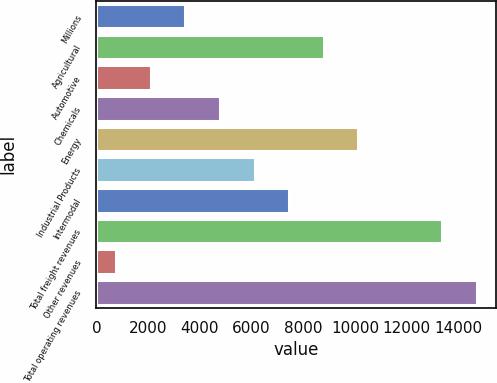Convert chart. <chart><loc_0><loc_0><loc_500><loc_500><bar_chart><fcel>Millions<fcel>Agricultural<fcel>Automotive<fcel>Chemicals<fcel>Energy<fcel>Industrial Products<fcel>Intermodal<fcel>Total freight revenues<fcel>Other revenues<fcel>Total operating revenues<nl><fcel>3444.6<fcel>8793.8<fcel>2107.3<fcel>4781.9<fcel>10131.1<fcel>6119.2<fcel>7456.5<fcel>13373<fcel>770<fcel>14710.3<nl></chart> 